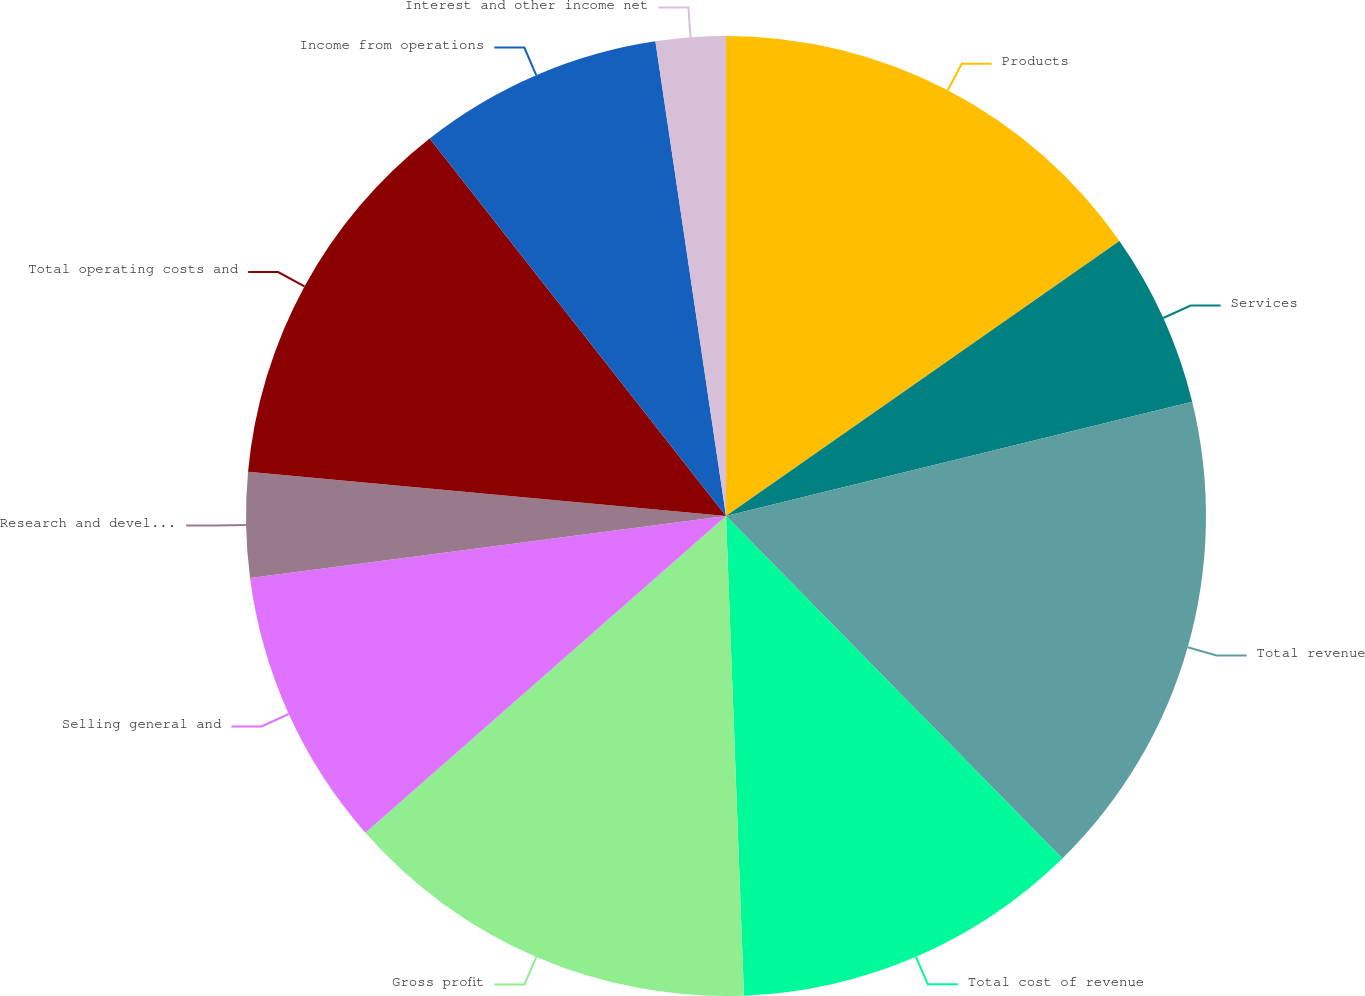Convert chart. <chart><loc_0><loc_0><loc_500><loc_500><pie_chart><fcel>Products<fcel>Services<fcel>Total revenue<fcel>Total cost of revenue<fcel>Gross profit<fcel>Selling general and<fcel>Research and development<fcel>Total operating costs and<fcel>Income from operations<fcel>Interest and other income net<nl><fcel>15.29%<fcel>5.88%<fcel>16.47%<fcel>11.76%<fcel>14.12%<fcel>9.41%<fcel>3.53%<fcel>12.94%<fcel>8.24%<fcel>2.35%<nl></chart> 